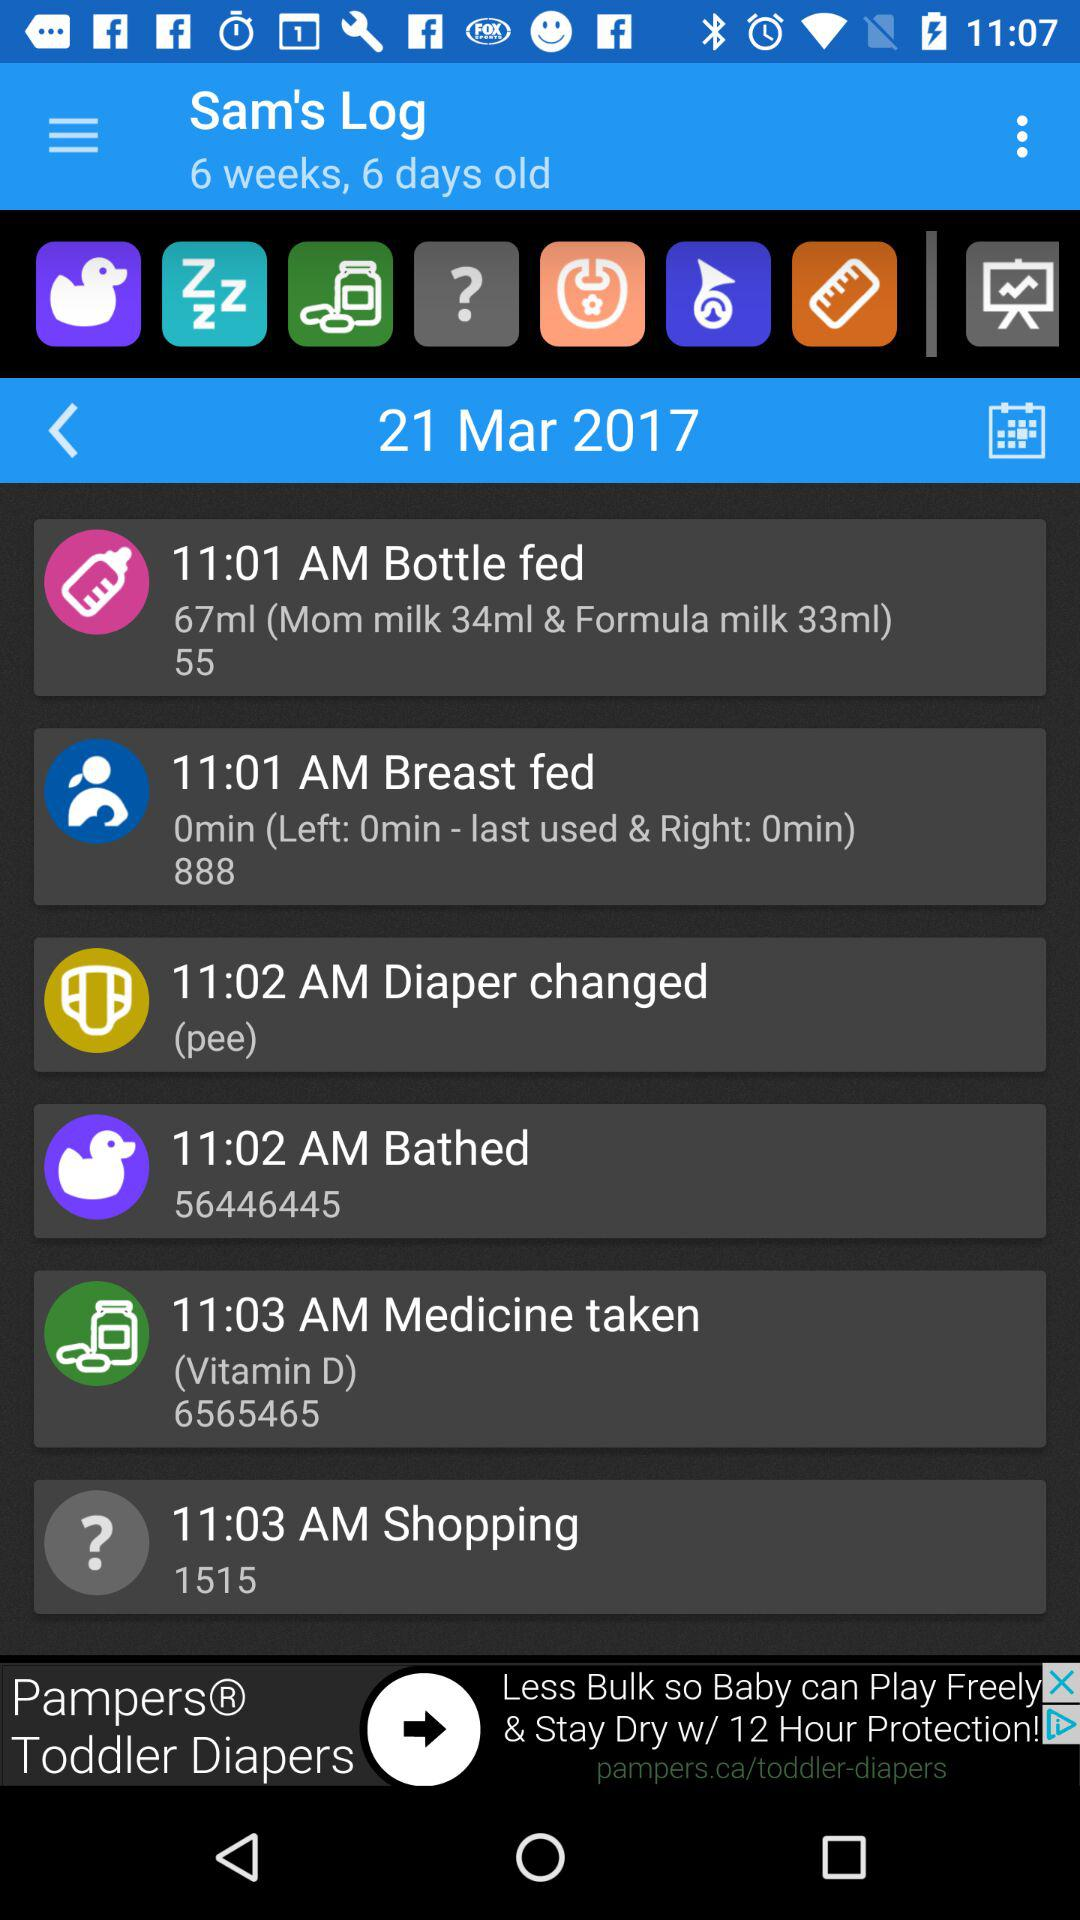What is the quantity of formula milk and mom milk? The quantities of formula milk and mom milk are 33 mL and 34 mL, respectively. 